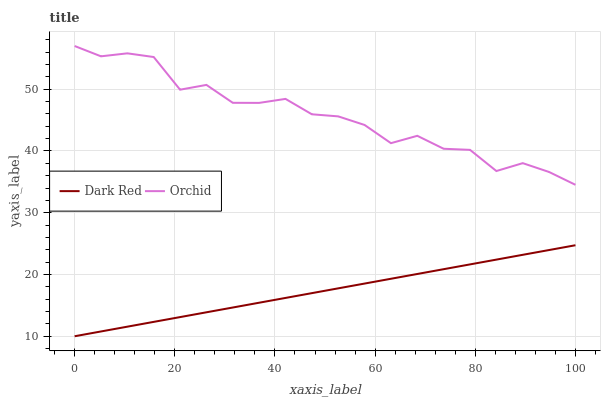Does Dark Red have the minimum area under the curve?
Answer yes or no. Yes. Does Orchid have the maximum area under the curve?
Answer yes or no. Yes. Does Orchid have the minimum area under the curve?
Answer yes or no. No. Is Dark Red the smoothest?
Answer yes or no. Yes. Is Orchid the roughest?
Answer yes or no. Yes. Is Orchid the smoothest?
Answer yes or no. No. Does Dark Red have the lowest value?
Answer yes or no. Yes. Does Orchid have the lowest value?
Answer yes or no. No. Does Orchid have the highest value?
Answer yes or no. Yes. Is Dark Red less than Orchid?
Answer yes or no. Yes. Is Orchid greater than Dark Red?
Answer yes or no. Yes. Does Dark Red intersect Orchid?
Answer yes or no. No. 